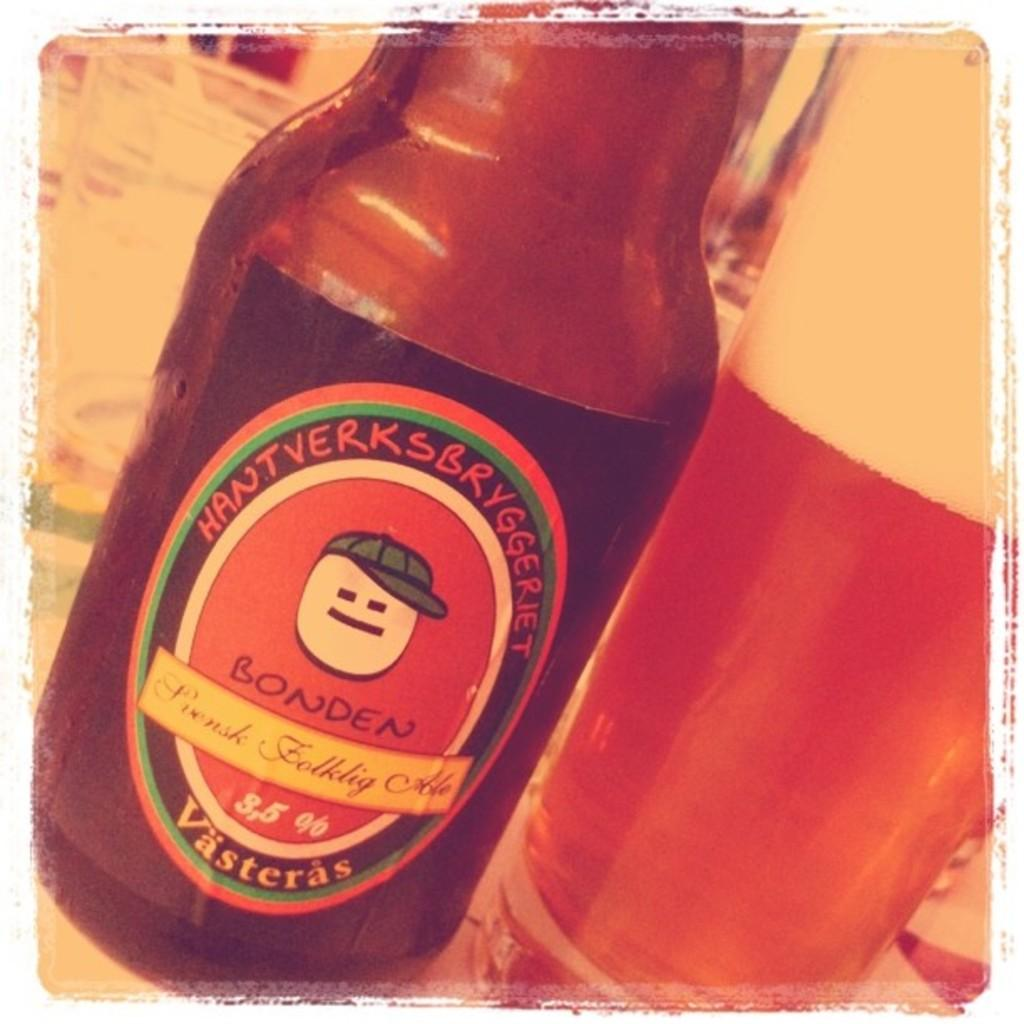<image>
Provide a brief description of the given image. A bottle of Bonden beer is sitting next to a glass. 